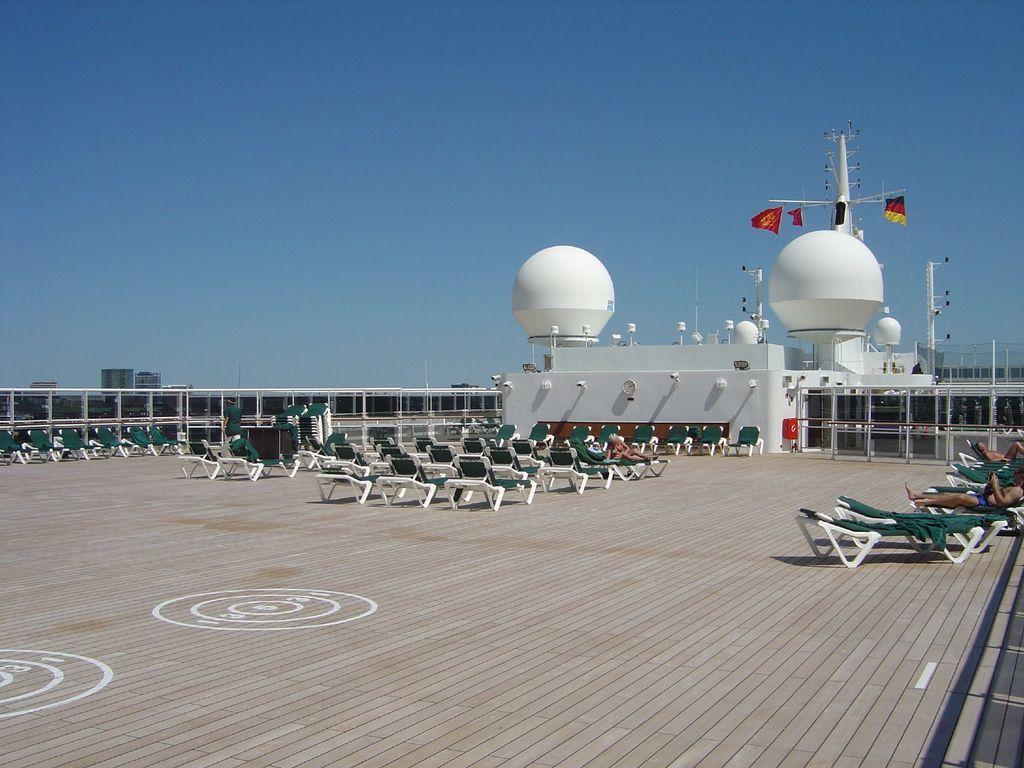Can you describe this image briefly? In the picture I can see chairs, a few people lying on the chairs, I can see white color objects, flags, poles and the blue color sky in the background 